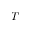Convert formula to latex. <formula><loc_0><loc_0><loc_500><loc_500>T</formula> 